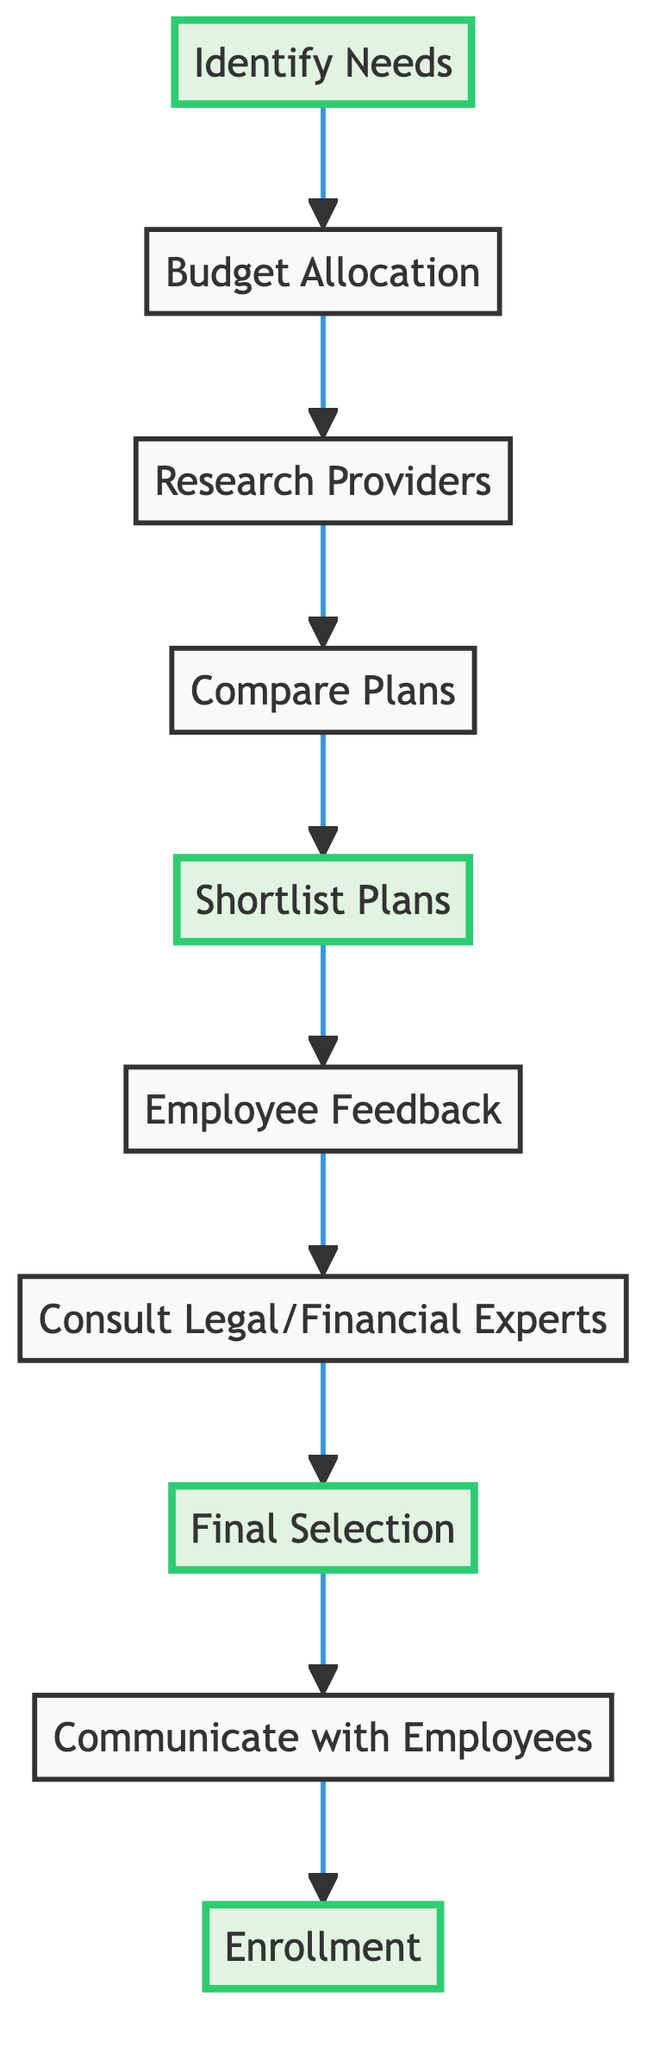What is the first step in the health insurance plan selection process? The first step in the process, as indicated by the flow chart, is "Identify Needs". This is shown at the starting point of the diagram that leads directly to the next step.
Answer: Identify Needs How many steps are in the health insurance plan selection process? By counting each step represented within the flow chart, there are a total of ten distinct steps indicated.
Answer: 10 What follows the "Budget Allocation" step? After "Budget Allocation", the next step in the flow chart is "Research Providers". This is determined by tracing the arrows from the first step to the subsequent step.
Answer: Research Providers What is the last step of the health insurance plan selection process? The final step shown in the diagram is "Enrollment", which is at the end of the flow chart reflecting the completion of the selection process.
Answer: Enrollment Which step involves seeking feedback from employees? The step that involves gathering feedback from employees is labeled as "Employee Feedback", which is located after "Shortlist Plans" and before "Consult Legal/Financial Experts" in the flow chart.
Answer: Employee Feedback How many steps are highlighted in the diagram? The diagram highlights four steps, specifically "Identify Needs", "Shortlist Plans", "Final Selection", and "Enrollment", which are visually emphasized through coloration.
Answer: 4 Which process step connects "Compare Plans" and "Shortlist Plans"? The connecting step between "Compare Plans" and "Shortlist Plans" is "D", which indicates the direct flow from evaluating various plans to creating a shortlist based on the evaluations.
Answer: Shortlist Plans What step requires consultation with legal or financial experts? The step that requires consulting with legal and financial experts is labeled "Consult Legal/Financial Experts", which is adjacent to "Employee Feedback" and precedes "Final Selection".
Answer: Consult Legal/Financial Experts What is the main purpose of the "Final Selection" step? The main purpose of the "Final Selection" step is to choose the most appropriate health insurance plan for the company and its employees, as indicated directly in the flow chart description.
Answer: Select the most appropriate health insurance plan 